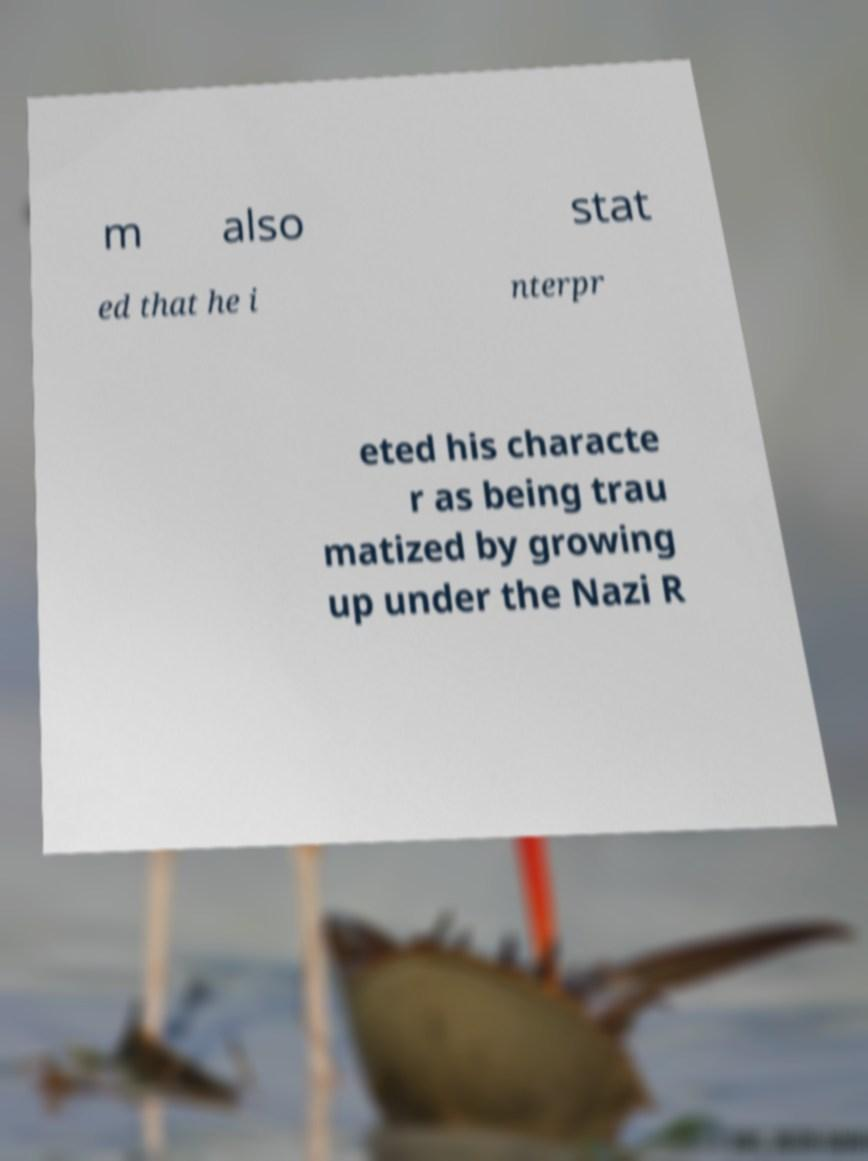Can you accurately transcribe the text from the provided image for me? m also stat ed that he i nterpr eted his characte r as being trau matized by growing up under the Nazi R 